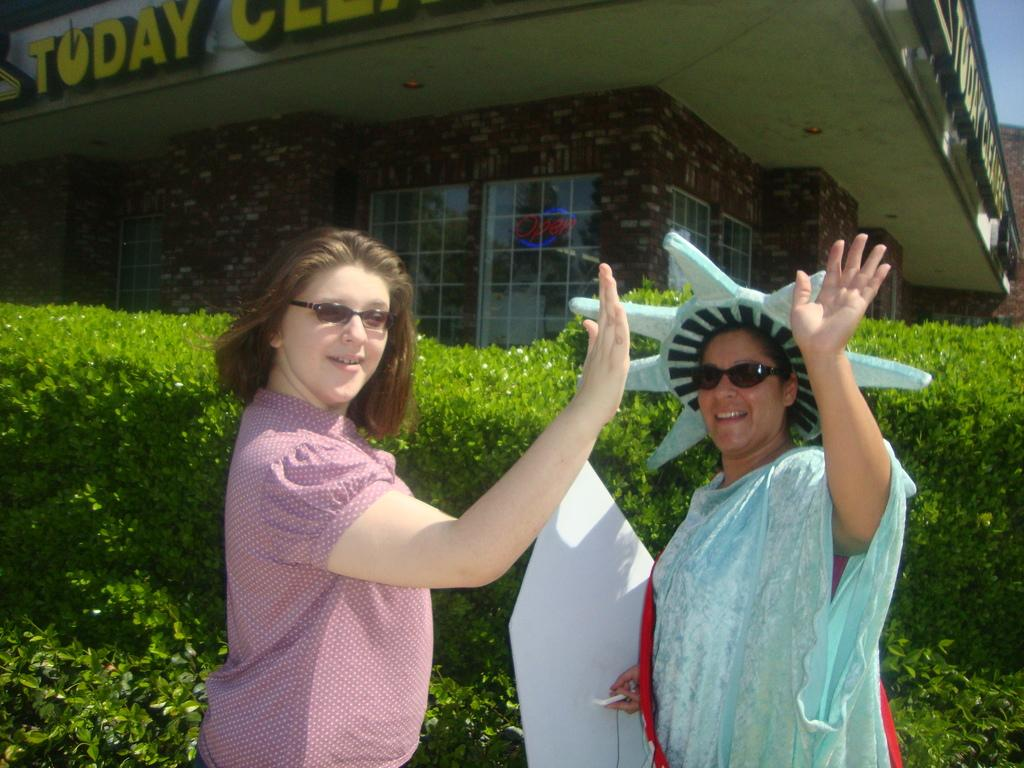How many people are in the foreground of the picture? There are two women in the foreground of the picture. What else can be seen in the foreground of the picture besides the women? There are plants in the foreground of the picture. What is visible in the background of the picture? There is a building in the background of the picture. What part of the sky is visible in the image? The sky is visible at the top right of the image. What type of education can be seen being taught in the image? There is no indication of any education being taught in the image. What color is the copper brush visible in the image? There is no copper brush present in the image. 